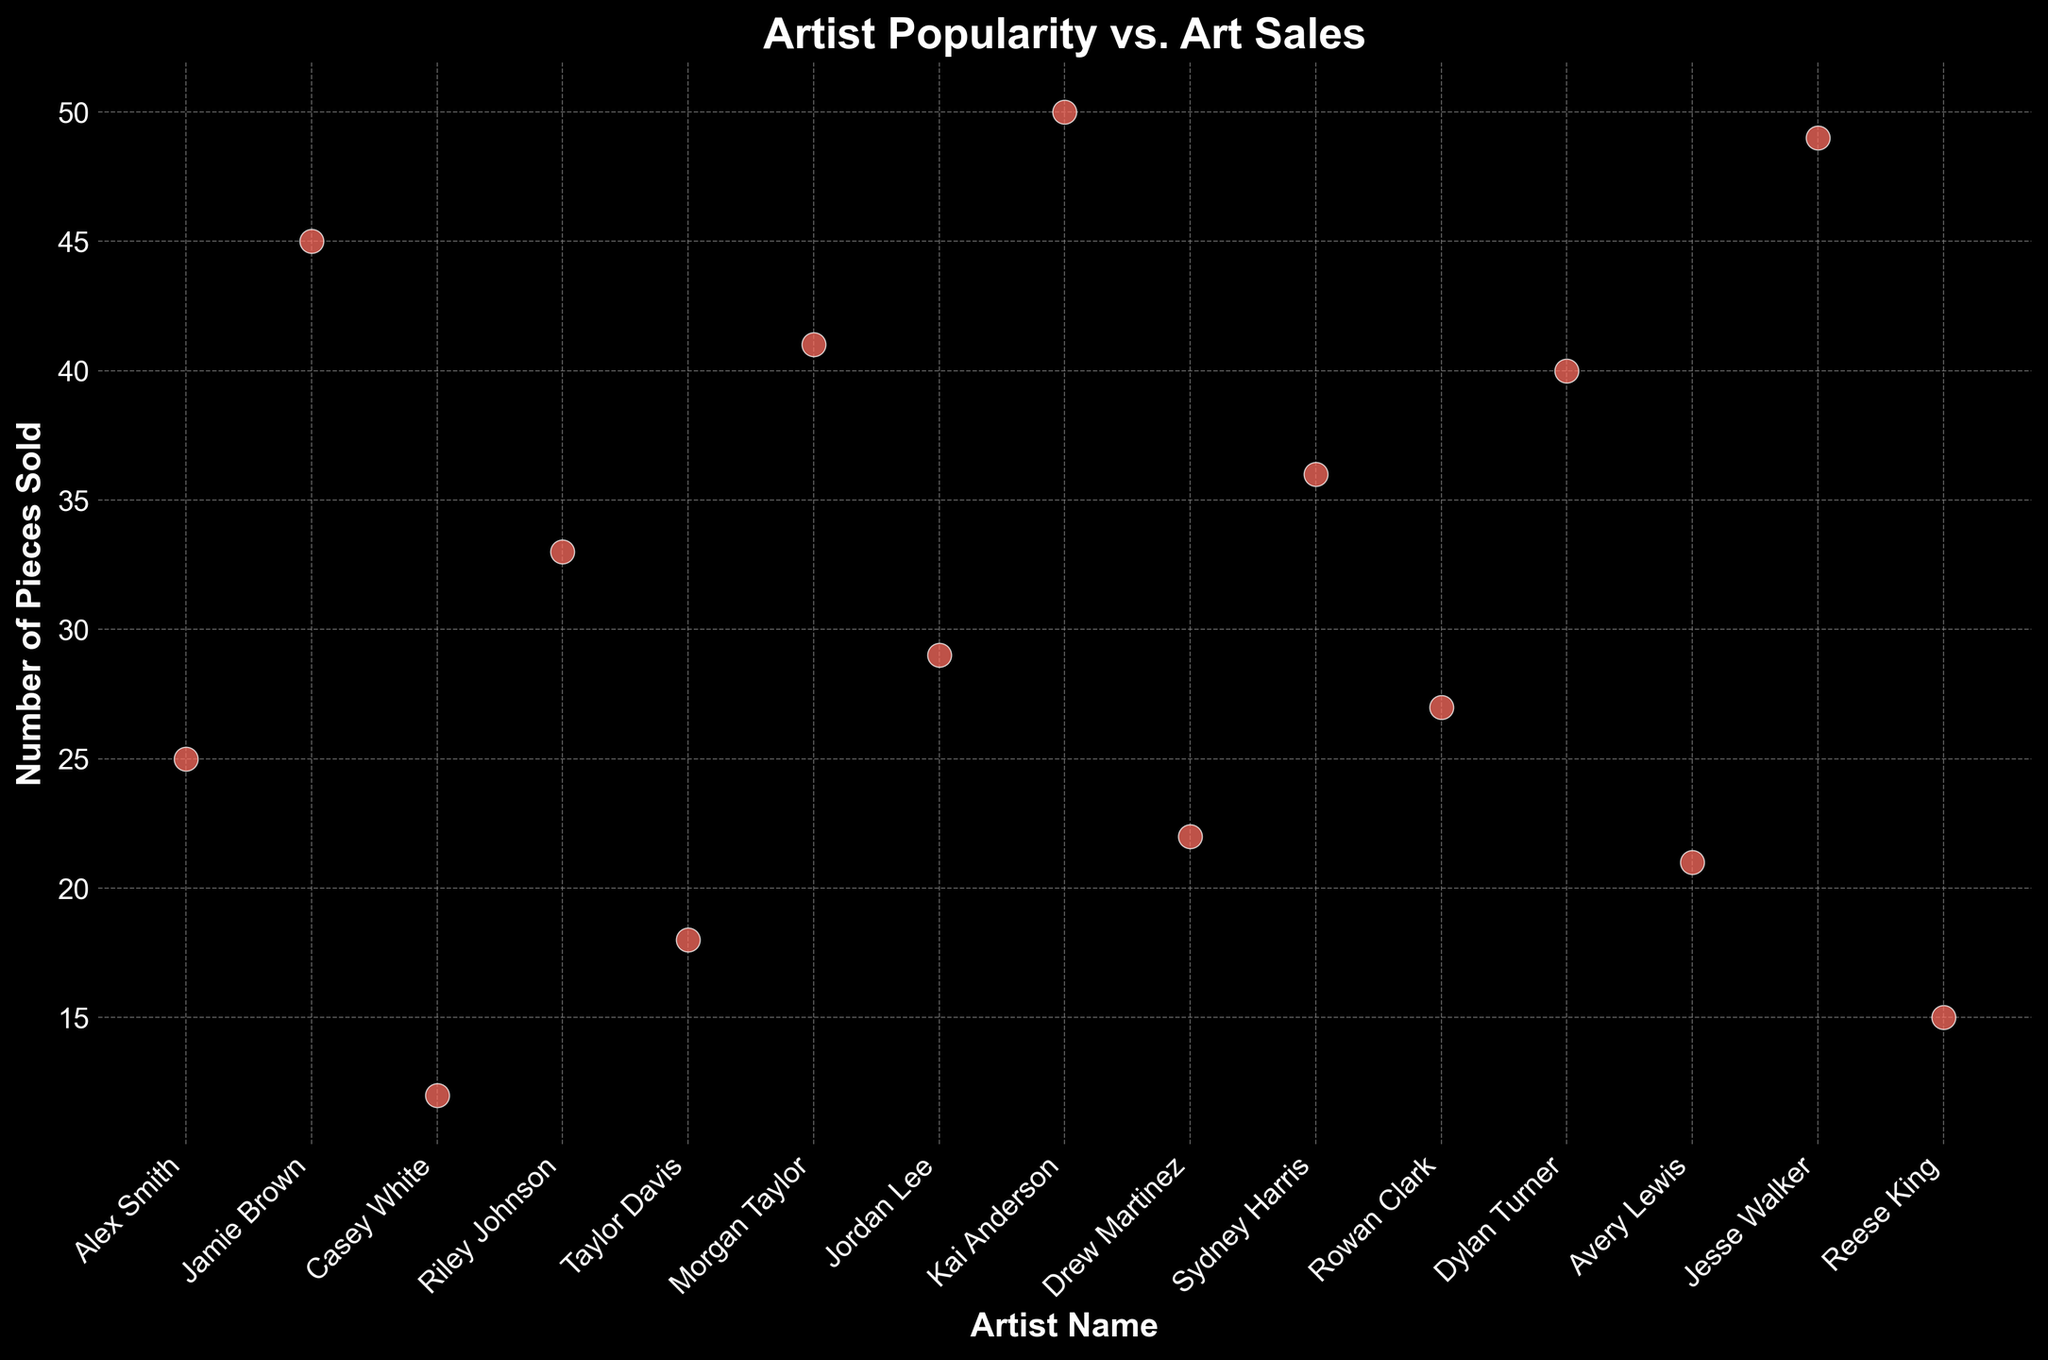What's the average number of pieces sold by the artists? To find the average, sum the numbers of pieces sold by all artists and divide by the number of artists. Sum = 25+45+12+33+18+41+29+50+22+36+27+40+21+49+15 = 463. There are 15 artists. Average = 463 / 15 ≈ 30.87
Answer: 30.87 Which artist sold the most pieces and how many? Locate the artist name with the highest data point on the y-axis. Kai Anderson sold 50 pieces, which is the maximum among all artists.
Answer: Kai Anderson, 50 Who sold more pieces, Riley Johnson or Taylor Davis? Refer to the y-axis values for these artists. Riley Johnson sold 33 pieces, and Taylor Davis sold 18 pieces. Therefore, Riley Johnson sold more.
Answer: Riley Johnson What's the total number of pieces sold by Jamie Brown and Jesse Walker? Sum the numbers of pieces sold by Jamie Brown and Jesse Walker. Jamie sold 45 pieces, and Jesse sold 49 pieces. Total = 45 + 49 = 94
Answer: 94 Which artist sold the least number of pieces? Identify the artist name with the lowest data point on the y-axis. Casey White sold 12 pieces, which is the minimum among all artists.
Answer: Casey White How many artists sold more than 30 pieces? Count the artists with y-axis values greater than 30. The artists are Jamie Brown (45), Riley Johnson (33), Morgan Taylor (41), Kai Anderson (50), Sydney Harris (36), Dylan Turner (40), and Jesse Walker (49). There are 7 in total.
Answer: 7 What is the difference in the number of pieces sold between Jordan Lee and Avery Lewis? Subtract the number of pieces sold by Avery Lewis from that by Jordan Lee. Jordan Lee sold 29 pieces, and Avery Lewis sold 21 pieces. Difference = 29 - 21 = 8
Answer: 8 What's the median number of pieces sold by the artists? Arrange the pieces sold in ascending order: 12, 15, 18, 21, 22, 25, 27, 29, 33, 36, 40, 41, 45, 49, 50. The middle value (8th in the list) is 29.
Answer: 29 